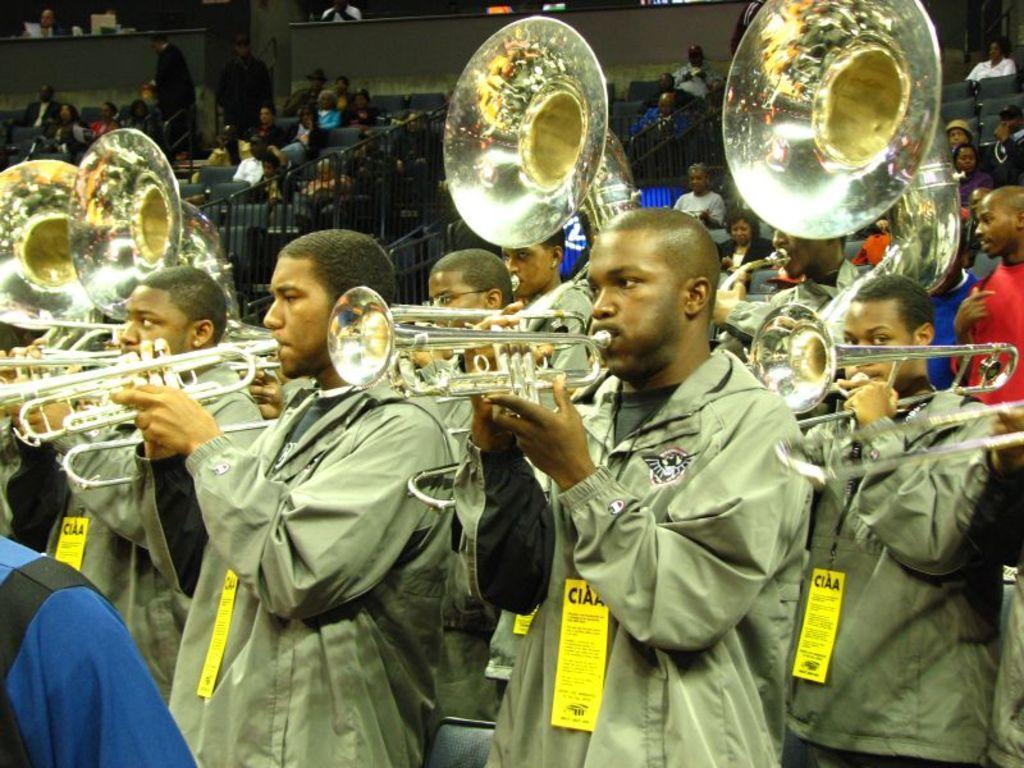Describe this image in one or two sentences. In this image I can see the group of people are playing the musical instruments. In the background I can see the railing and few more people with different color dresses. 